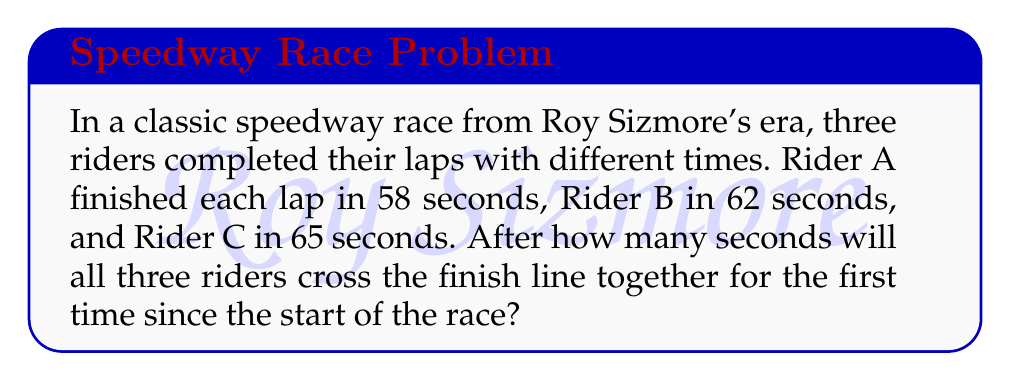Teach me how to tackle this problem. To solve this problem, we need to find the least common multiple (LCM) of the three lap times:

1. First, let's factor each lap time:
   58 = 2 × 29
   62 = 2 × 31
   65 = 5 × 13

2. The LCM will include the highest power of each prime factor:
   LCM = 2 × 29 × 31 × 5 × 13

3. Calculate the result:
   $$ \text{LCM} = 2 \times 29 \times 31 \times 5 \times 13 = 116,870 $$

4. Therefore, after 116,870 seconds, all three riders will cross the finish line together for the first time since the start of the race.

5. We can verify this:
   116,870 ÷ 58 = 2,015 (whole number of laps for Rider A)
   116,870 ÷ 62 = 1,885 (whole number of laps for Rider B)
   116,870 ÷ 65 = 1,798 (whole number of laps for Rider C)
Answer: 116,870 seconds 